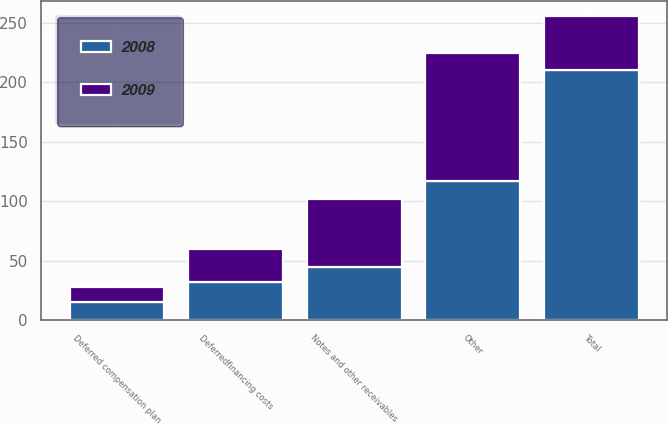<chart> <loc_0><loc_0><loc_500><loc_500><stacked_bar_chart><ecel><fcel>Deferredfinancing costs<fcel>Deferred compensation plan<fcel>Notes and other receivables<fcel>Other<fcel>Total<nl><fcel>2008<fcel>32.4<fcel>15.2<fcel>45.1<fcel>117.4<fcel>210.1<nl><fcel>2009<fcel>27.4<fcel>13<fcel>57.2<fcel>107.3<fcel>45.1<nl></chart> 